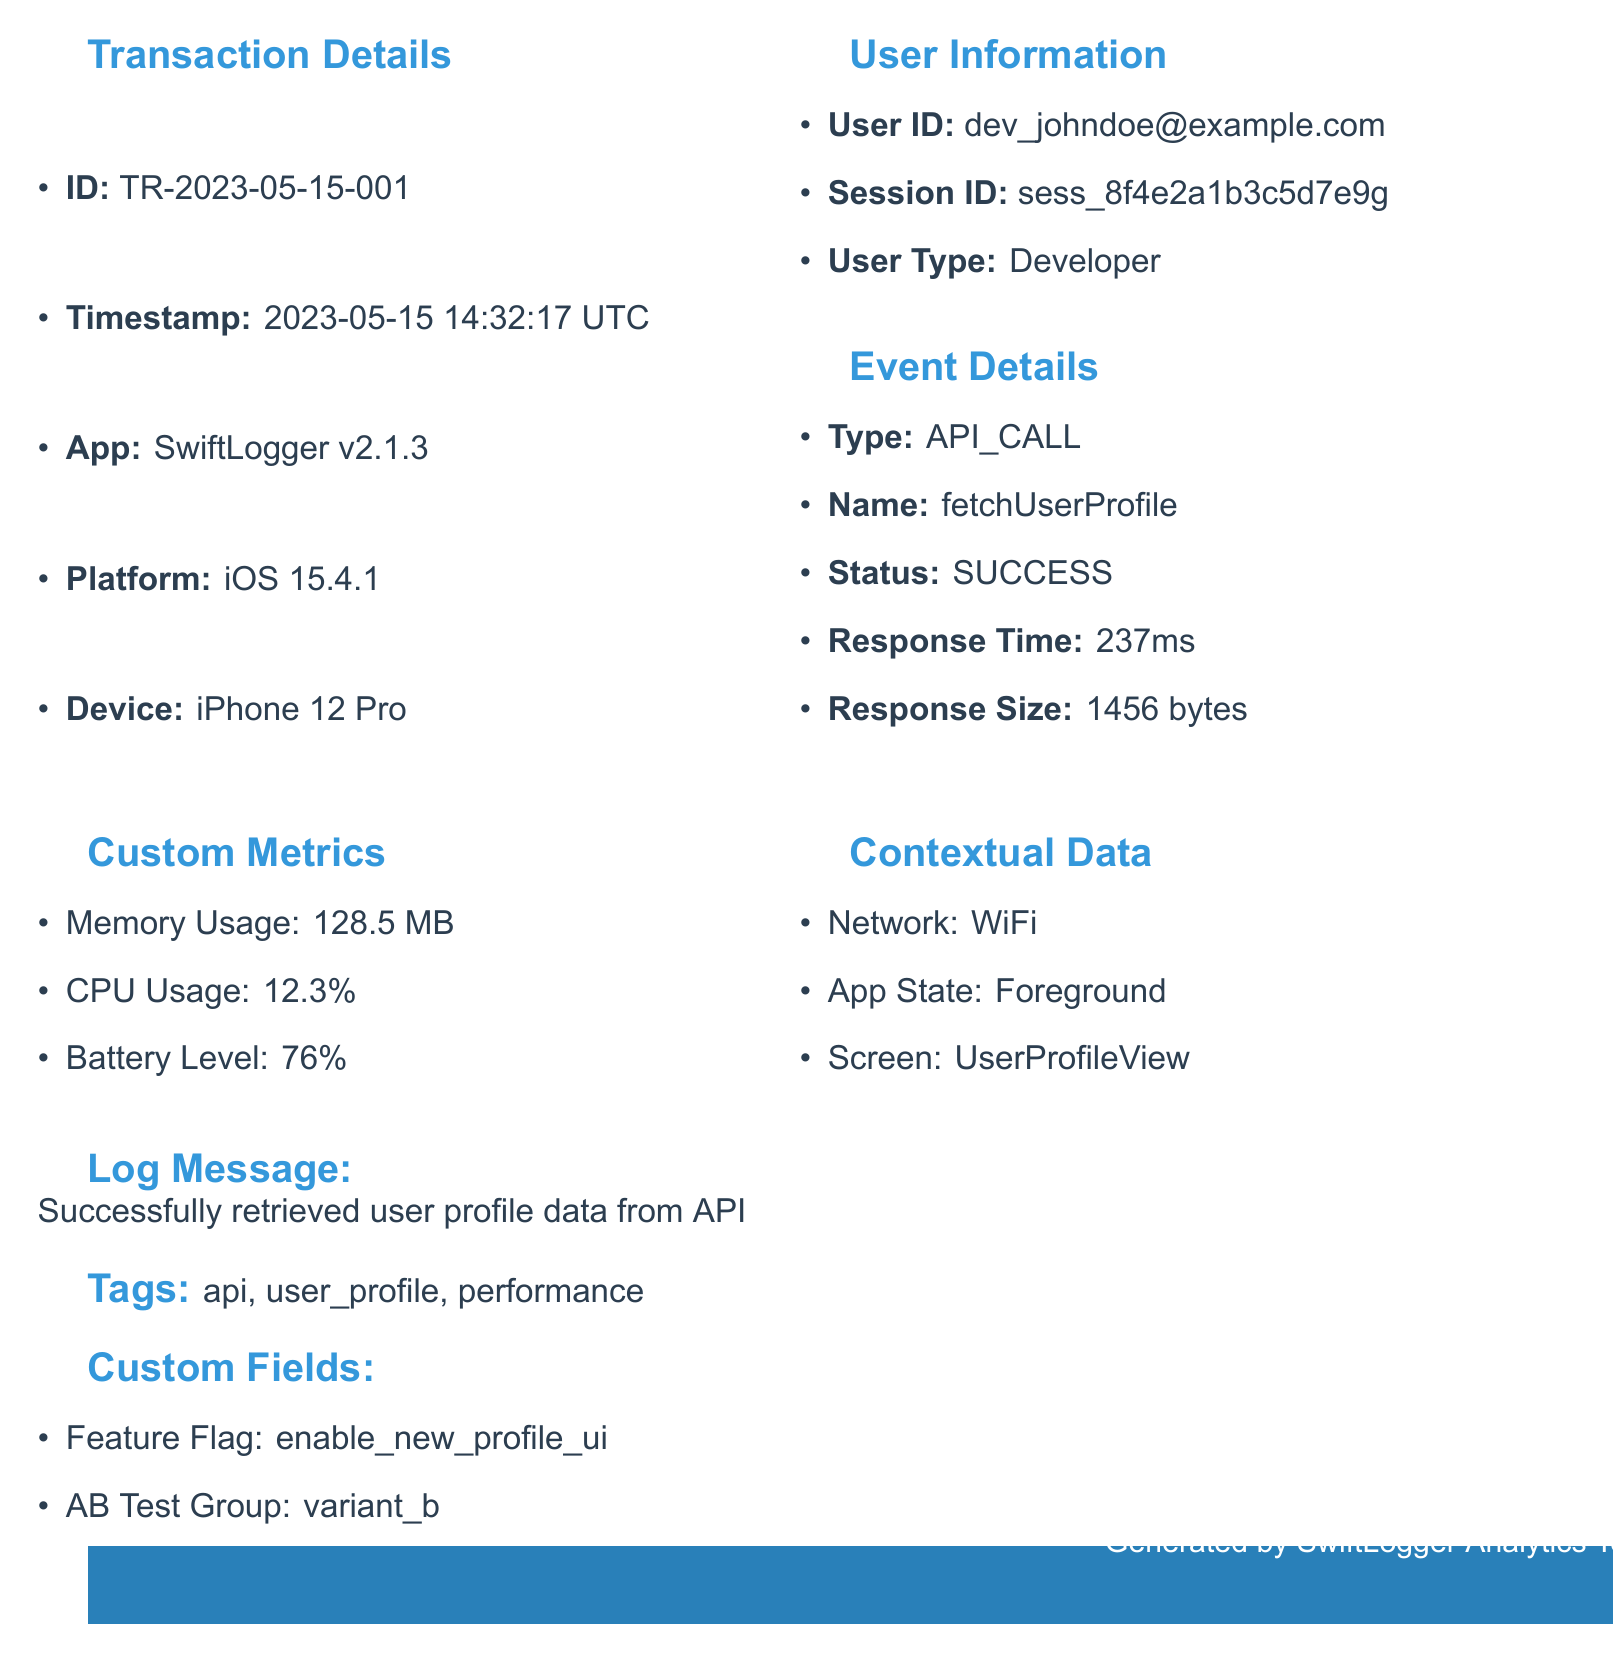What is the transaction ID? The transaction ID is listed under "Transaction Details" in the document.
Answer: TR-2023-05-15-001 What is the response time for the API call? The response time can be found in the "Event Details" section of the document.
Answer: 237 What is the user ID of the developer? The user ID is specified in the "User Information" section.
Answer: dev_johndoe@example.com What is the battery level during the transaction? The battery level is detailed in the "Custom Metrics" section of the document.
Answer: 76 What event status is recorded for the API call? The event status appears in the "Event Details" section of the document.
Answer: SUCCESS What future plan is mentioned for the logging tool? Future plans can be found in the "Future Plans" section of the developer notes.
Answer: Implement machine learning for anomaly detection What is the average session duration according to the analytics data? The average session duration is included in the "analyticsData" section of the document.
Answer: 432 What feature flag is included in the custom fields? The feature flag can be found in the "Custom Fields" section at the end of the document.
Answer: enable_new_profile_ui What is the log retention period? The log retention period is mentioned under the "configurationSettings" section of the document.
Answer: 30 